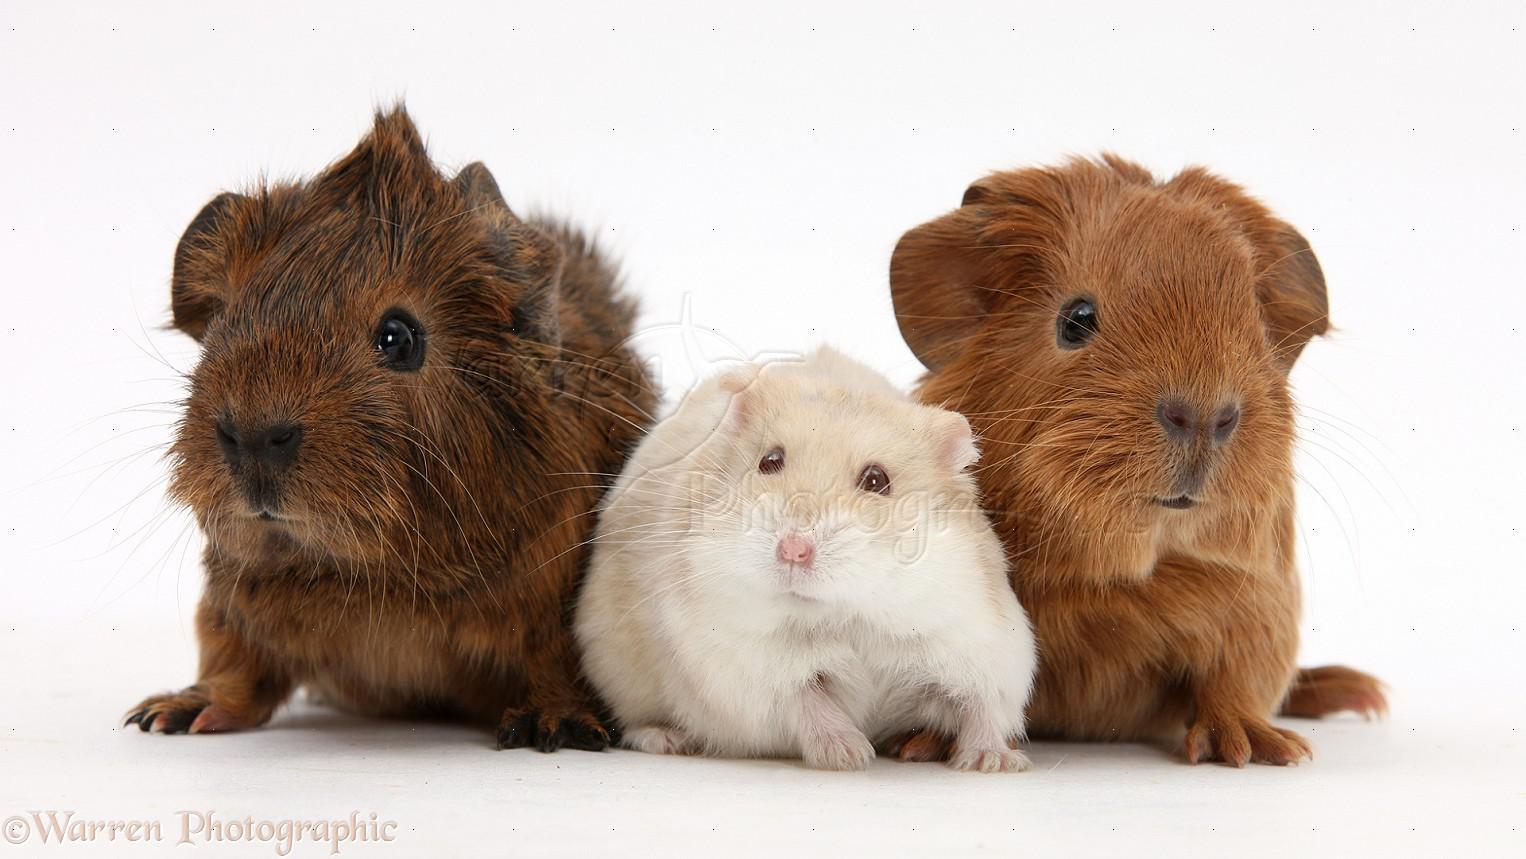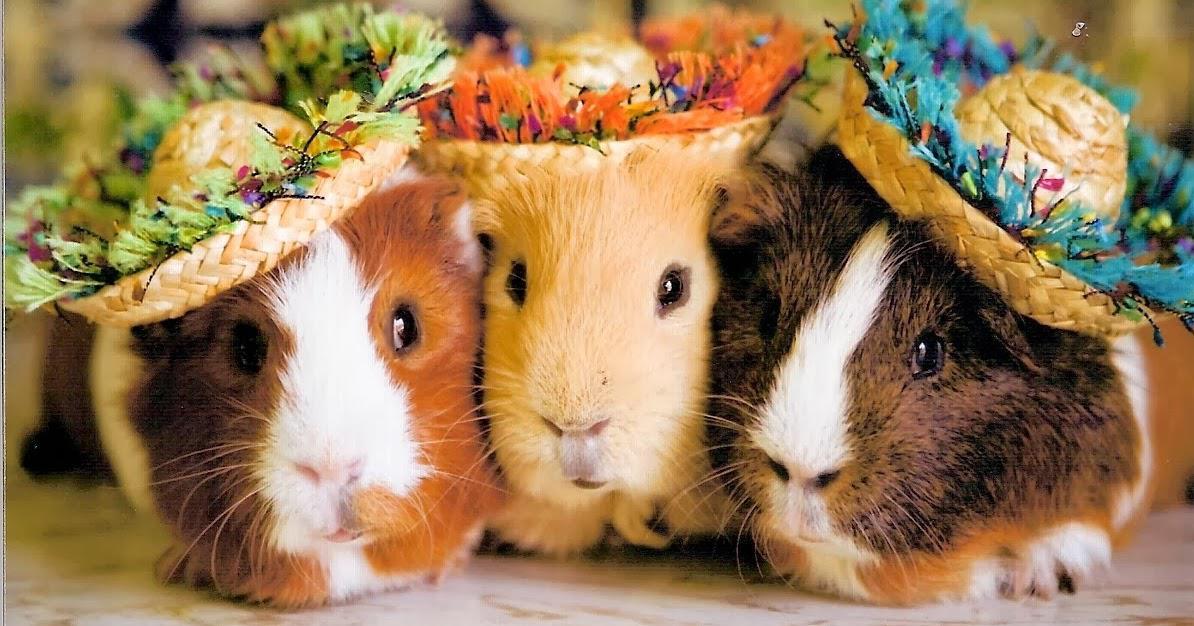The first image is the image on the left, the second image is the image on the right. Examine the images to the left and right. Is the description "there are 3 guinea pigs in each image pair" accurate? Answer yes or no. Yes. The first image is the image on the left, the second image is the image on the right. For the images displayed, is the sentence "In the right image, the animals have something covering their heads." factually correct? Answer yes or no. Yes. 